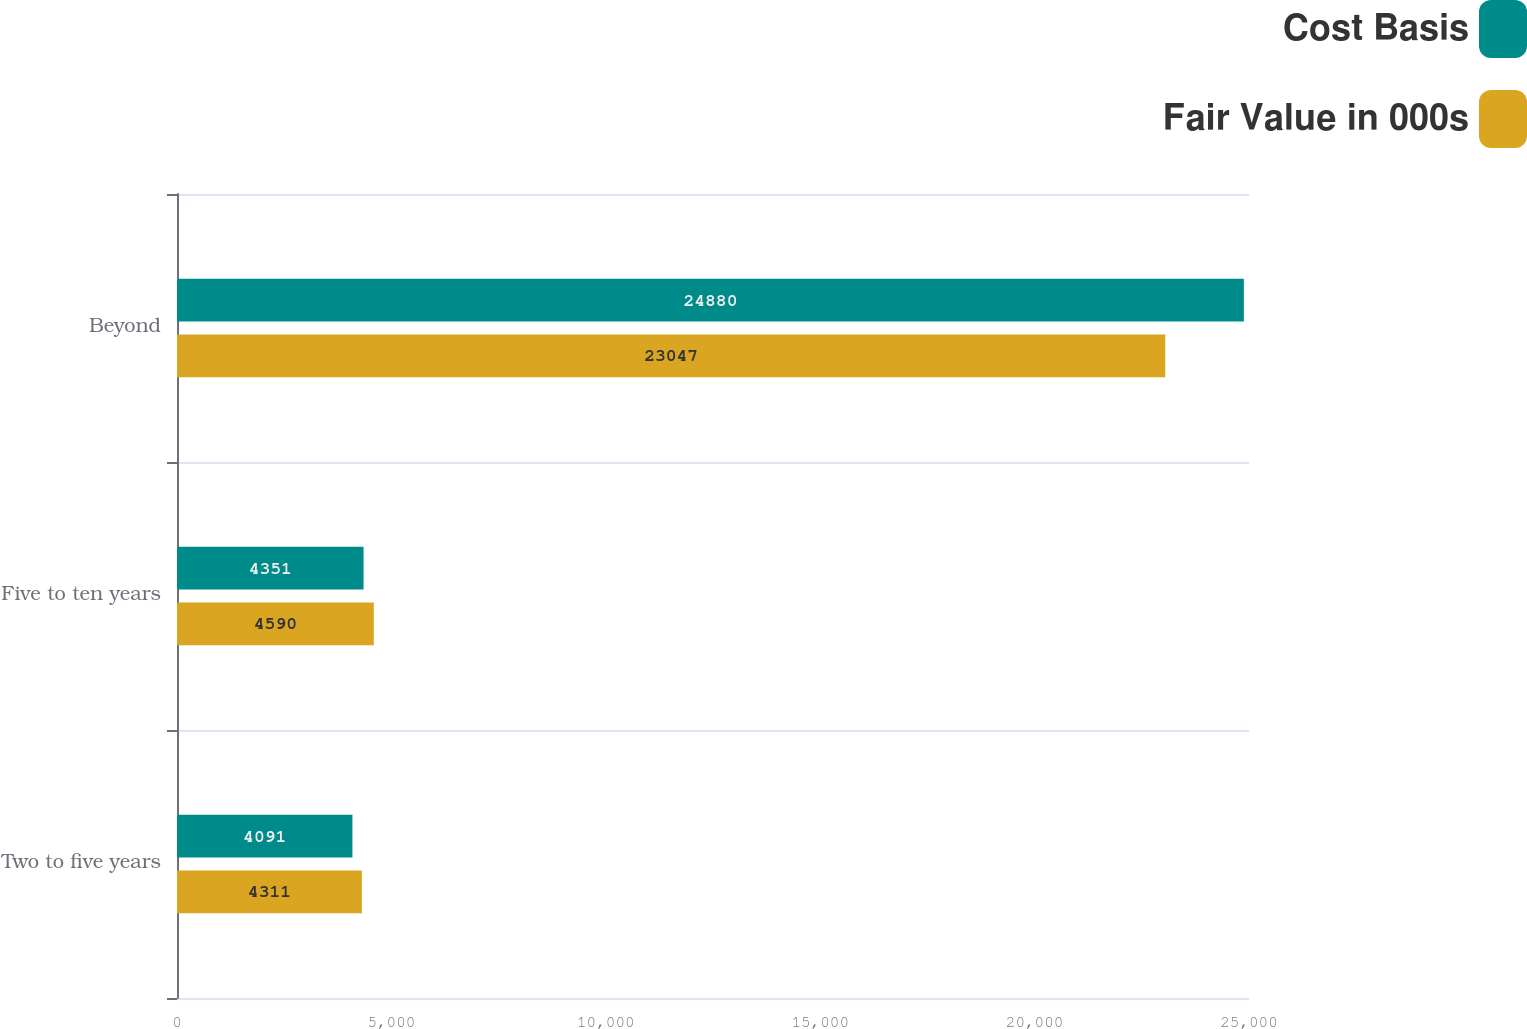<chart> <loc_0><loc_0><loc_500><loc_500><stacked_bar_chart><ecel><fcel>Two to five years<fcel>Five to ten years<fcel>Beyond<nl><fcel>Cost Basis<fcel>4091<fcel>4351<fcel>24880<nl><fcel>Fair Value in 000s<fcel>4311<fcel>4590<fcel>23047<nl></chart> 